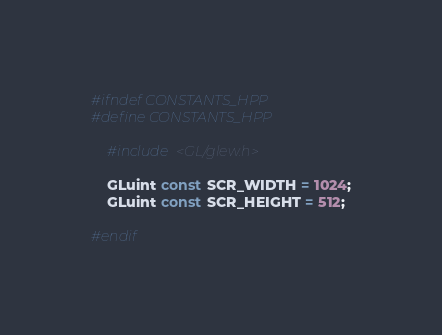Convert code to text. <code><loc_0><loc_0><loc_500><loc_500><_C++_>#ifndef CONSTANTS_HPP
#define CONSTANTS_HPP

	#include <GL/glew.h>

	GLuint const SCR_WIDTH = 1024;
	GLuint const SCR_HEIGHT = 512;

#endif
</code> 